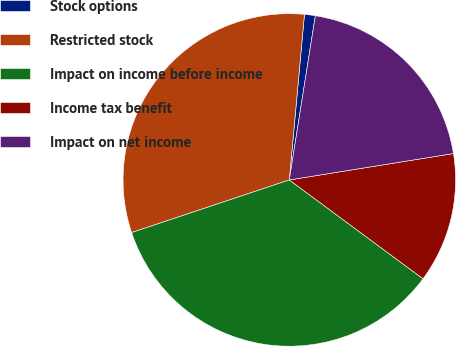Convert chart to OTSL. <chart><loc_0><loc_0><loc_500><loc_500><pie_chart><fcel>Stock options<fcel>Restricted stock<fcel>Impact on income before income<fcel>Income tax benefit<fcel>Impact on net income<nl><fcel>1.05%<fcel>31.58%<fcel>34.74%<fcel>12.67%<fcel>19.96%<nl></chart> 